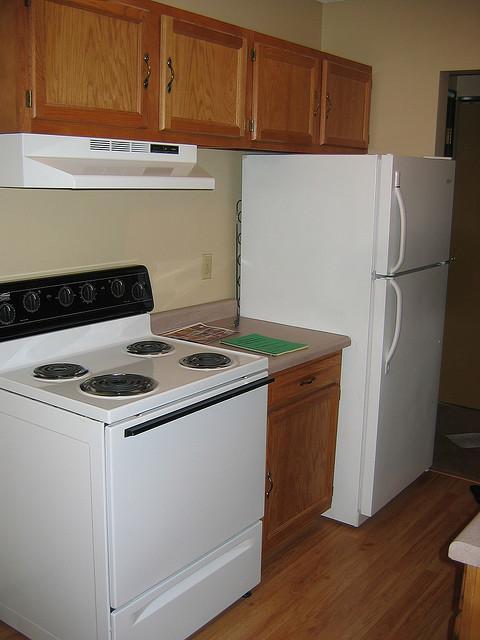How many burners does the stove have?
Give a very brief answer. 4. How many ovens are there?
Give a very brief answer. 1. How many cow ears do you see?
Give a very brief answer. 0. 